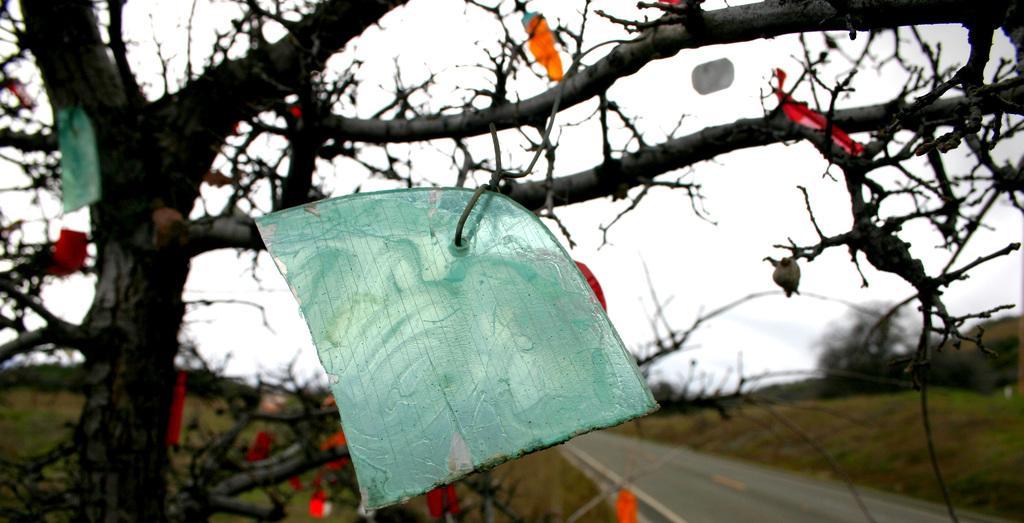Please provide a concise description of this image. In this picture I can see there are few trees, a road and the sky is clear. 